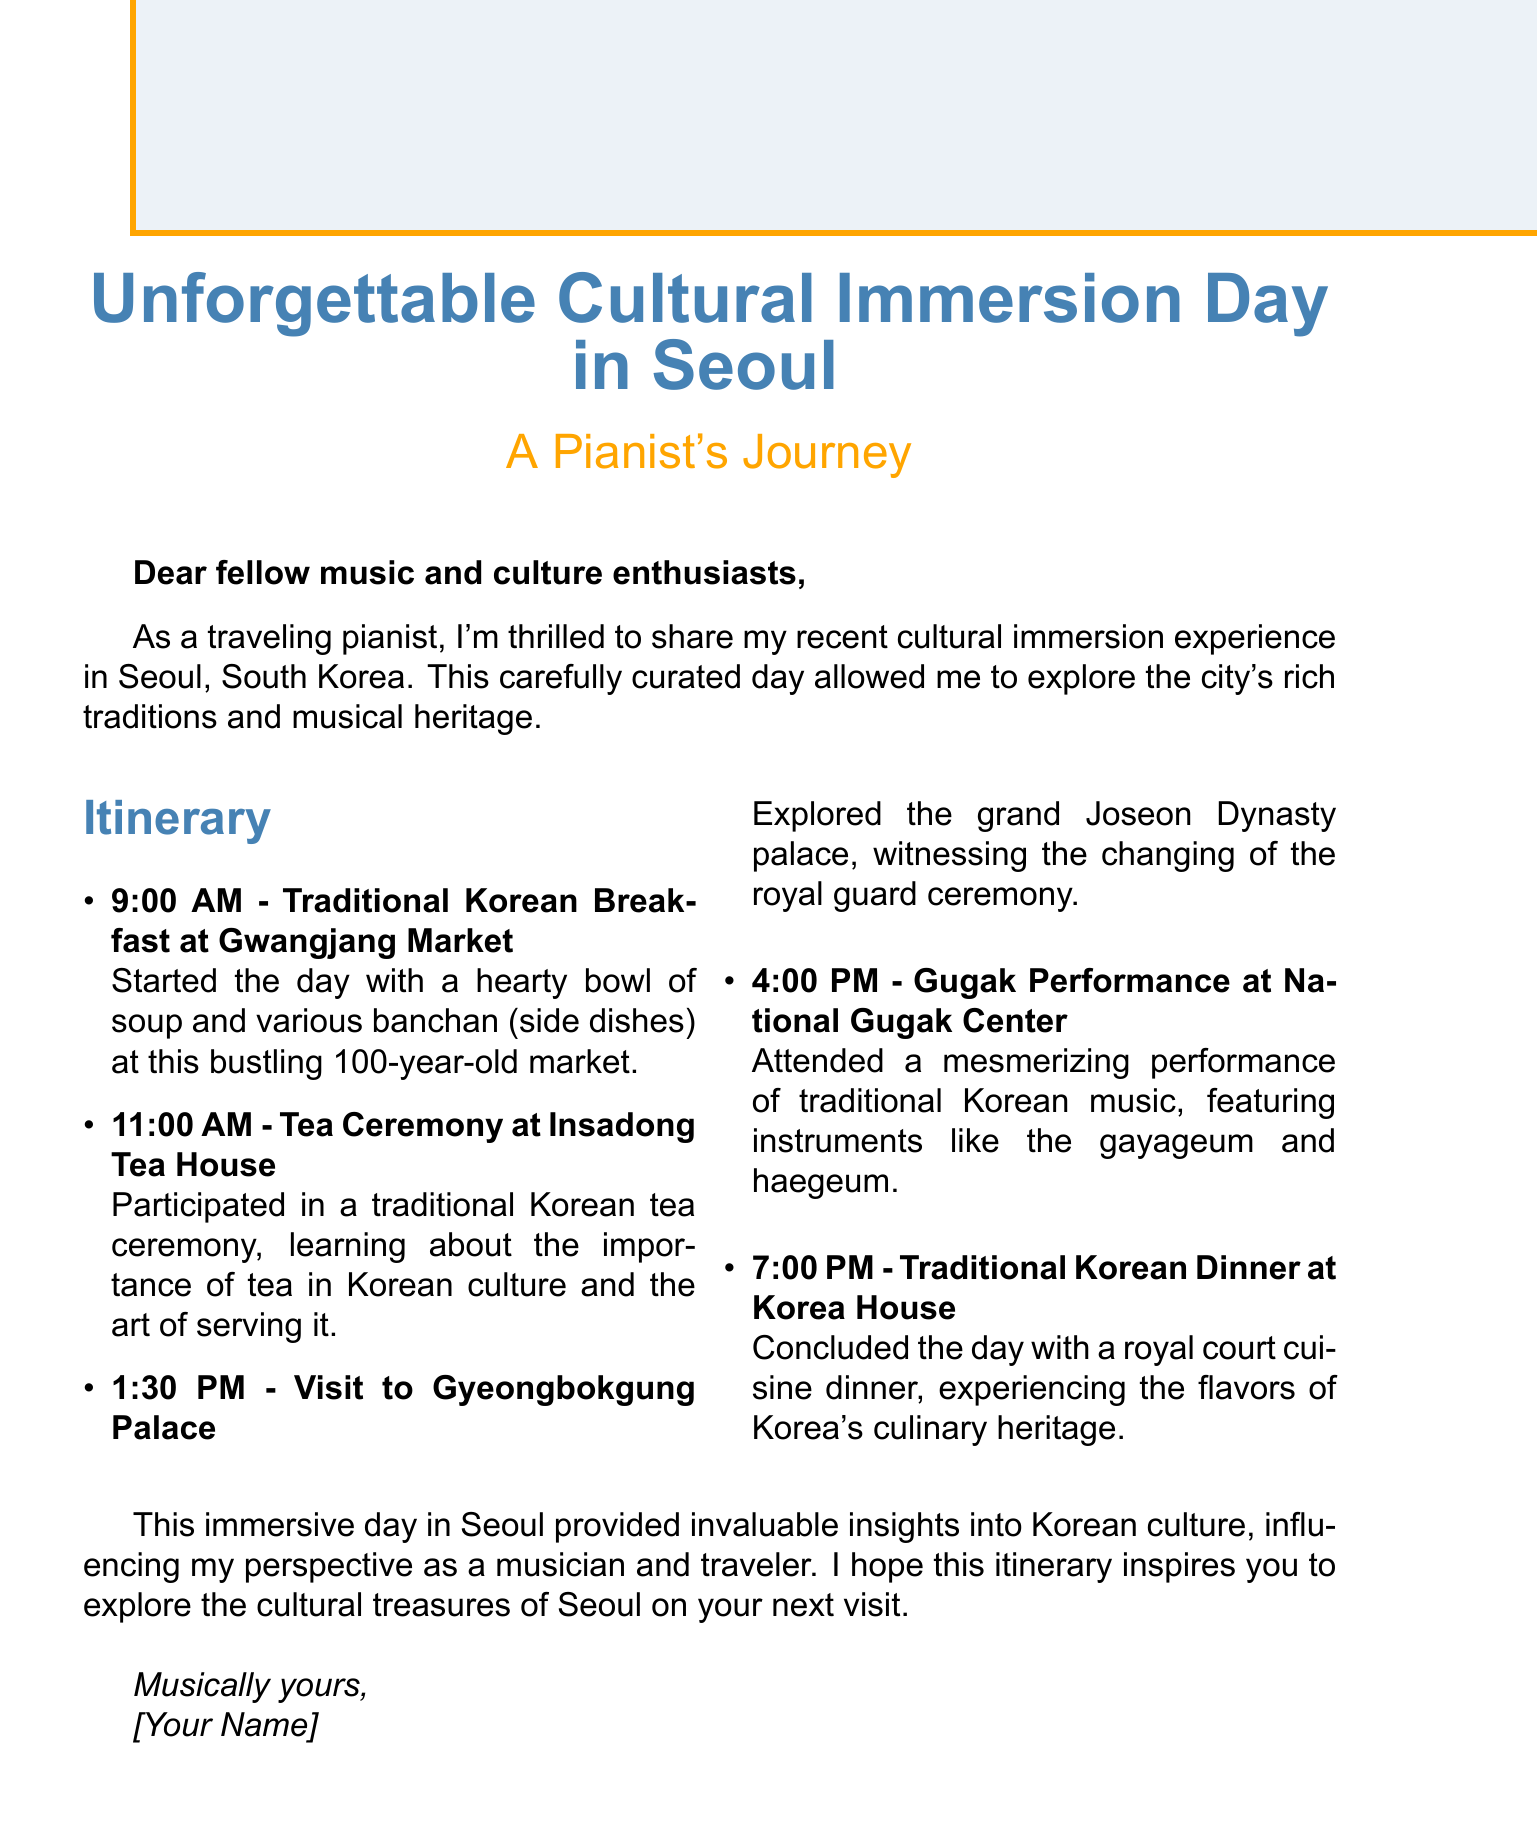What time does the tea ceremony begin? The tea ceremony at Insadong Tea House starts at 11:00 AM.
Answer: 11:00 AM What is the activity after visiting Gyeongbokgung Palace? After visiting Gyeongbokgung Palace, the next activity is the Gugak Performance at the National Gugak Center.
Answer: Gugak Performance What type of cuisine is served at Korea House? The dinner at Korea House features royal court cuisine, which reflects Korea's culinary heritage.
Answer: Royal court cuisine How many activities are listed in the itinerary? The email outlines five distinct activities planned for the day in Seoul.
Answer: Five Which musical instruments are mentioned during the Gugak performance? The instruments featured in the Gugak performance include the gayageum and haegeum.
Answer: Gayageum and haegeum Who is sharing the cultural immersion experience? The person sharing the experience is a traveling pianist, providing insights into cultural immersion.
Answer: Traveling pianist What is the overall reflection on the day in Seoul? The reflection mentions that the immersion day provided invaluable insights into Korean culture, influencing the author's perspective as a musician.
Answer: Invaluable insights into Korean culture What is the closing statement of the email? The closing statement expresses hope that the itinerary inspires recipients to explore Seoul's cultural treasures.
Answer: Hope this itinerary inspires you 